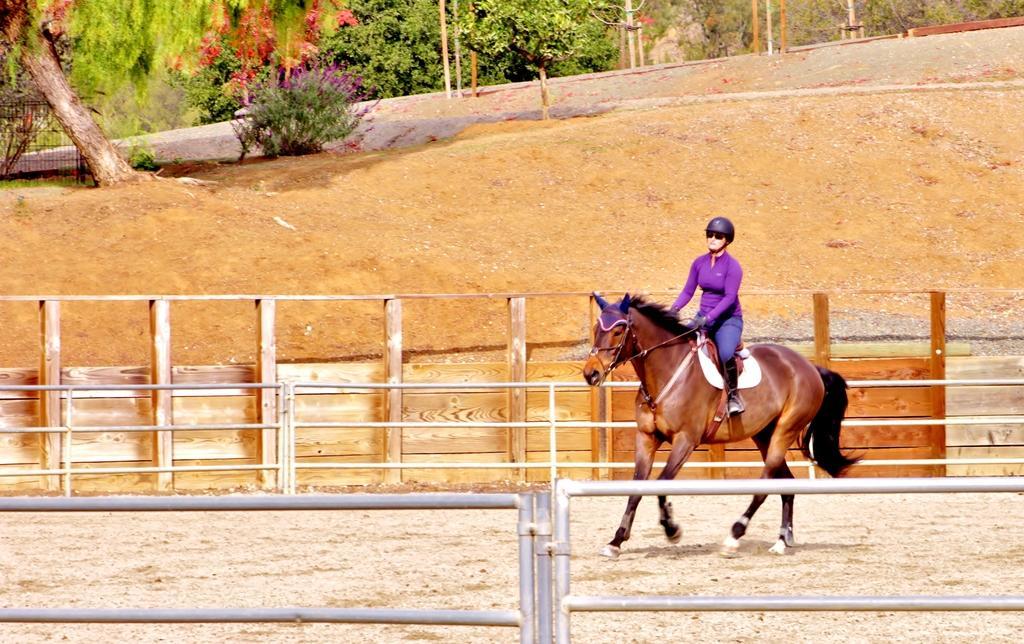Please provide a concise description of this image. As we can see in the image there are trees, plant and a woman riding horse. 